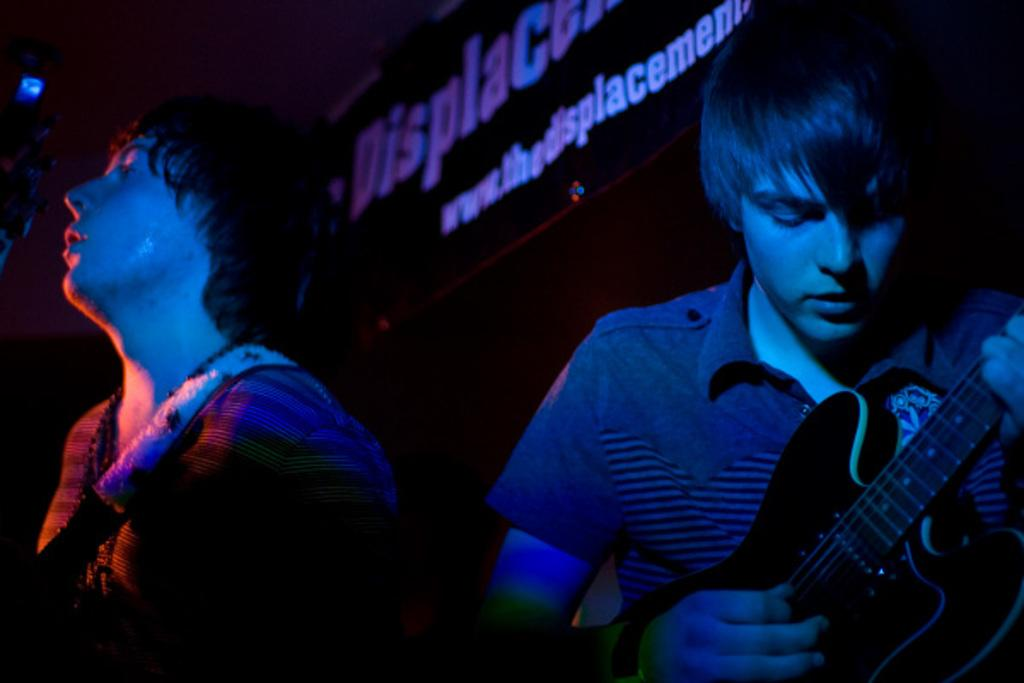How many people are in the image? There are two people in the image. What is one person doing in the image? One person is playing a guitar. What can be seen in the background of the image? There is a hoarding in the background of the image. What is the name of the throne in the image? There is no throne present in the image. What type of oil can be seen dripping from the guitar in the image? There is no oil present in the image, and the guitar is not depicted as dripping anything. 